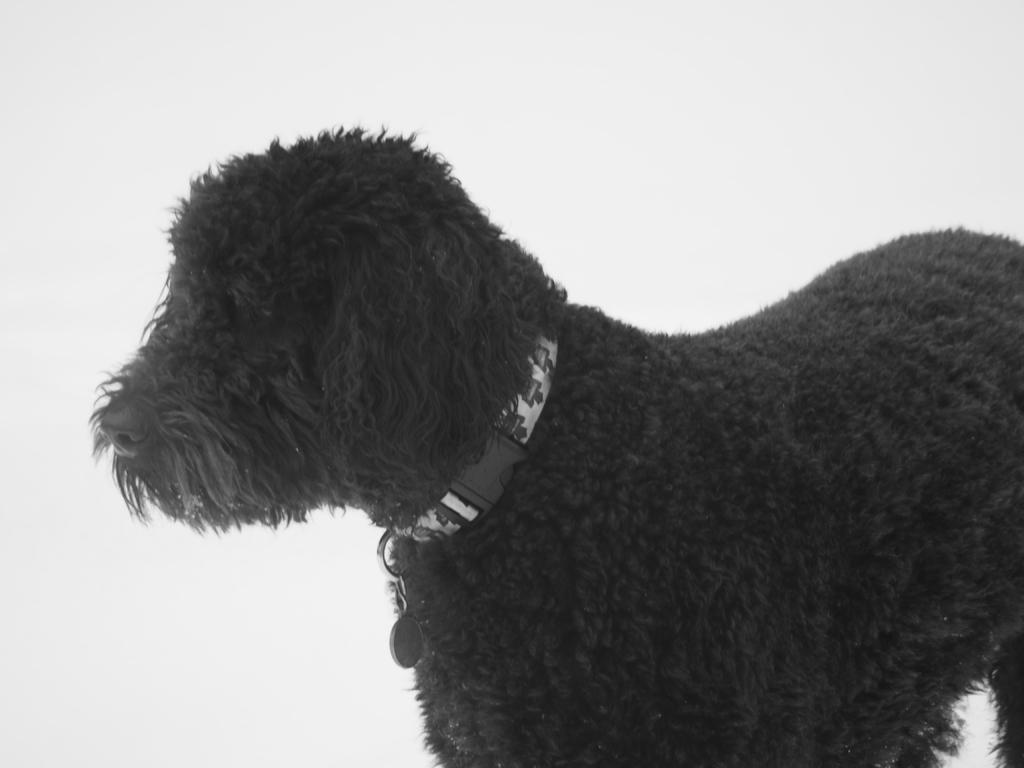What type of animal is in the image? There is a black color dog in the image. What is the dog wearing? The dog is wearing a dog neck belt. What color is the background of the image? The background of the image is white in color. Where is the mom in the image? There is no mom present in the image; it features a black color dog wearing a dog neck belt against a white background. 